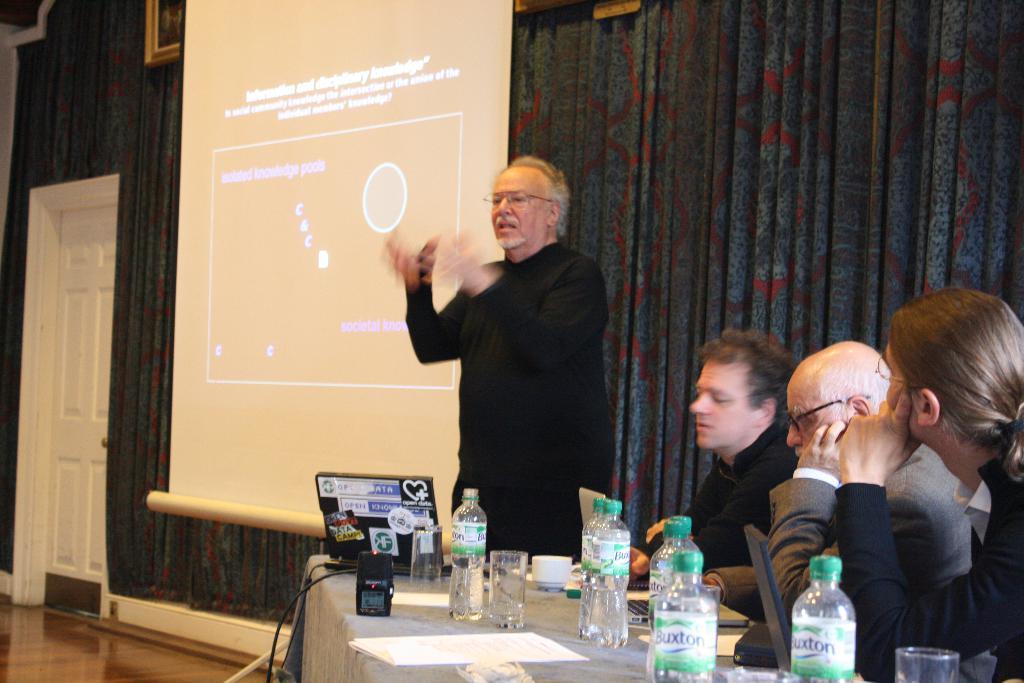In one or two sentences, can you explain what this image depicts? In this picture we can see man standing and talking and beside to him three men sitting on chairs and listening to him and here on table we can see bottles, glasses, laptop, device, cup, saucer and this side screen, wall, door, frame. 